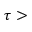Convert formula to latex. <formula><loc_0><loc_0><loc_500><loc_500>\tau ></formula> 